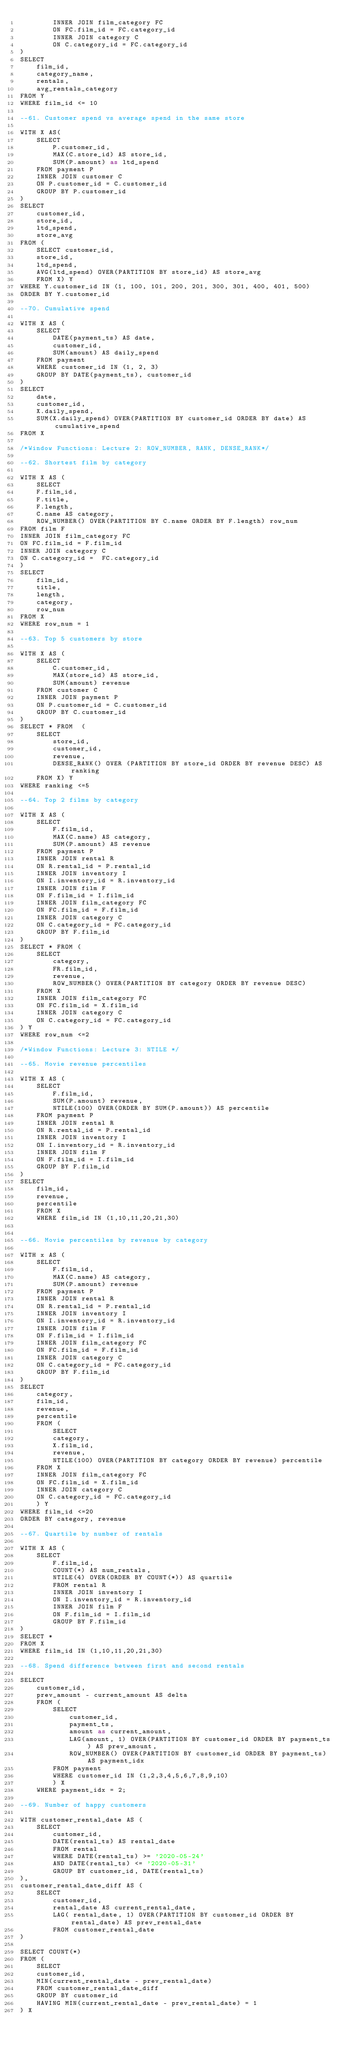Convert code to text. <code><loc_0><loc_0><loc_500><loc_500><_SQL_>        INNER JOIN film_category FC
        ON FC.film_id = FC.category_id
        INNER JOIN category C 
        ON C.category_id = FC.category_id
)
SELECT
    film_id,
    category_name,
    rentals,
    avg_rentals_category
FROM Y
WHERE film_id <= 10

--61. Customer spend vs average spend in the same store

WITH X AS(
    SELECT 
        P.customer_id, 
        MAX(C.store_id) AS store_id, 
        SUM(P.amount) as ltd_spend
    FROM payment P 
    INNER JOIN customer C 
    ON P.customer_id = C.customer_id
    GROUP BY P.customer_id
)
SELECT 
    customer_id, 
    store_id, 
    ltd_spend, 
    store_avg 
FROM (
    SELECT customer_id, 
    store_id, 
    ltd_spend, 
    AVG(ltd_spend) OVER(PARTITION BY store_id) AS store_avg
    FROM X) Y
WHERE Y.customer_id IN (1, 100, 101, 200, 201, 300, 301, 400, 401, 500)
ORDER BY Y.customer_id

--70. Cumulative spend

WITH X AS (
    SELECT 
        DATE(payment_ts) AS date, 
        customer_id, 
        SUM(amount) AS daily_spend
    FROM payment
    WHERE customer_id IN (1, 2, 3)
    GROUP BY DATE(payment_ts), customer_id
)
SELECT 
    date,
    customer_id,
    X.daily_spend,
    SUM(X.daily_spend) OVER(PARTITION BY customer_id ORDER BY date) AS cumulative_spend
FROM X

/*Window Functions: Lecture 2: ROW_NUMBER, RANK, DENSE_RANK*/

--62. Shortest film by category

WITH X AS (
    SELECT 
    F.film_id, 
    F.title, 
    F.length, 
    C.name AS category,
    ROW_NUMBER() OVER(PARTITION BY C.name ORDER BY F.length) row_num
FROM film F 
INNER JOIN film_category FC 
ON FC.film_id = F.film_id
INNER JOIN category C 
ON C.category_id =  FC.category_id
)
SELECT
    film_id,
    title,
    length,
    category,
    row_num
FROM X
WHERE row_num = 1

--63. Top 5 customers by store

WITH X AS (
    SELECT 
        C.customer_id,
        MAX(store_id) AS store_id,
        SUM(amount) revenue 
    FROM customer C
    INNER JOIN payment P
    ON P.customer_id = C.customer_id
    GROUP BY C.customer_id
)
SELECT * FROM  (
    SELECT 
        store_id, 
        customer_id,
        revenue,
        DENSE_RANK() OVER (PARTITION BY store_id ORDER BY revenue DESC) AS ranking
    FROM X) Y
WHERE ranking <=5

--64. Top 2 films by category

WITH X AS (
    SELECT
        F.film_id,
        MAX(C.name) AS category,
        SUM(P.amount) AS revenue
    FROM payment P
    INNER JOIN rental R 
    ON R.rental_id = P.rental_id
    INNER JOIN inventory I
    ON I.inventory_id = R.inventory_id
    INNER JOIN film F
    ON F.film_id = I.film_id
    INNER JOIN film_category FC
    ON FC.film_id = F.film_id
    INNER JOIN category C
    ON C.category_id = FC.category_id
    GROUP BY F.film_id
)
SELECT * FROM (
    SELECT
        category,
        FR.film_id,
        revenue,
        ROW_NUMBER() OVER(PARTITION BY category ORDER BY revenue DESC)
    FROM X
    INNER JOIN film_category FC
    ON FC.film_id = X.film_id
    INNER JOIN category C
    ON C.category_id = FC.category_id
) Y
WHERE row_num <=2

/*Window Functions: Lecture 3: NTILE */

--65. Movie revenue percentiles

WITH X AS (
    SELECT
        F.film_id, 
        SUM(P.amount) revenue,
        NTILE(100) OVER(ORDER BY SUM(P.amount)) AS percentile 
    FROM payment P 
    INNER JOIN rental R 
    ON R.rental_id = P.rental_id
    INNER JOIN inventory I 
    ON I.inventory_id = R.inventory_id
    INNER JOIN film F
    ON F.film_id = I.film_id
    GROUP BY F.film_id
)
SELECT
    film_id,
    revenue,
    percentile
    FROM X
    WHERE film_id IN (1,10,11,20,21,30)


--66. Movie percentiles by revenue by category

WITH x AS (
    SELECT
        F.film_id,
        MAX(C.name) AS category,
        SUM(P.amount) revenue
    FROM payment P
    INNER JOIN rental R
    ON R.rental_id = P.rental_id
    INNER JOIN inventory I
    ON I.inventory_id = R.inventory_id
    INNER JOIN film F
    ON F.film_id = I.film_id
    INNER JOIN film_category FC
    ON FC.film_id = F.film_id
    INNER JOIN category C
    ON C.category_id = FC.category_id
    GROUP BY F.film_id
)
SELECT
    category,
    film_id,
    revenue,
    percentile
    FROM (
        SELECT
        category,
        X.film_id,
        revenue,
        NTILE(100) OVER(PARTITION BY category ORDER BY revenue) percentile
    FROM X
    INNER JOIN film_category FC
    ON FC.film_id = X.film_id
    INNER JOIN category C
    ON C.category_id = FC.category_id
    ) Y
WHERE film_id <=20
ORDER BY category, revenue

--67. Quartile by number of rentals

WITH X AS (
    SELECT
        F.film_id,
        COUNT(*) AS num_rentals,
        NTILE(4) OVER(ORDER BY COUNT(*)) AS quartile
        FROM rental R
        INNER JOIN inventory I
        ON I.inventory_id = R.inventory_id
        INNER JOIN film F
        ON F.film_id = I.film_id
        GROUP BY F.film_id
)
SELECT *
FROM X
WHERE film_id IN (1,10,11,20,21,30)

--68. Spend difference between first and second rentals

SELECT 
    customer_id,
    prev_amount - current_amount AS delta
    FROM (
        SELECT
            customer_id,
            payment_ts,
            amount as current_amount,
            LAG(amount, 1) OVER(PARTITION BY customer_id ORDER BY payment_ts ) AS prev_amount,
            ROW_NUMBER() OVER(PARTITION BY customer_id ORDER BY payment_ts) AS payment_idx
        FROM payment
        WHERE customer_id IN (1,2,3,4,5,6,7,8,9,10)
        ) X
    WHERE payment_idx = 2;

--69. Number of happy customers

WITH customer_rental_date AS (
    SELECT
        customer_id,
        DATE(rental_ts) AS rental_date
        FROM rental
        WHERE DATE(rental_ts) >= '2020-05-24'
        AND DATE(rental_ts) <= '2020-05-31'
        GROUP BY customer_id, DATE(rental_ts)
),
customer_rental_date_diff AS (
    SELECT
        customer_id,
        rental_date AS current_rental_date,
        LAG( rental_date, 1) OVER(PARTITION BY customer_id ORDER BY rental_date) AS prev_rental_date
        FROM customer_rental_date
)

SELECT COUNT(*) 
FROM (
    SELECT
    customer_id,
    MIN(current_rental_date - prev_rental_date)
    FROM customer_rental_date_diff
    GROUP BY customer_id
    HAVING MIN(current_rental_date - prev_rental_date) = 1
) X
</code> 